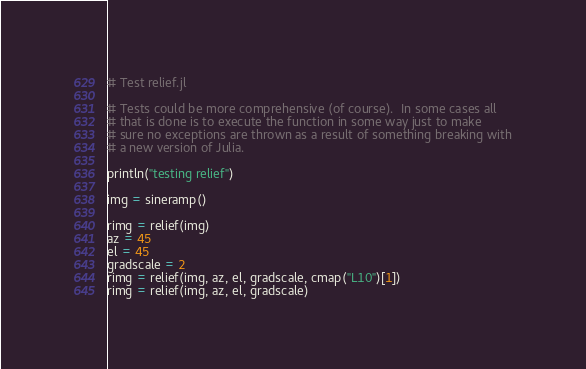<code> <loc_0><loc_0><loc_500><loc_500><_Julia_># Test relief.jl

# Tests could be more comprehensive (of course).  In some cases all
# that is done is to execute the function in some way just to make
# sure no exceptions are thrown as a result of something breaking with
# a new version of Julia.

println("testing relief")

img = sineramp()

rimg = relief(img)
az = 45
el = 45
gradscale = 2
rimg = relief(img, az, el, gradscale, cmap("L10")[1])
rimg = relief(img, az, el, gradscale)
</code> 